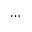Convert formula to latex. <formula><loc_0><loc_0><loc_500><loc_500>\cdots</formula> 